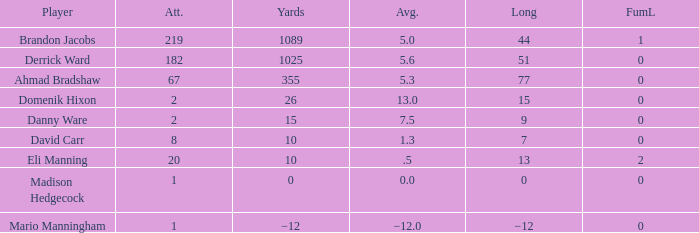What is Domenik Hixon's average rush? 13.0. 